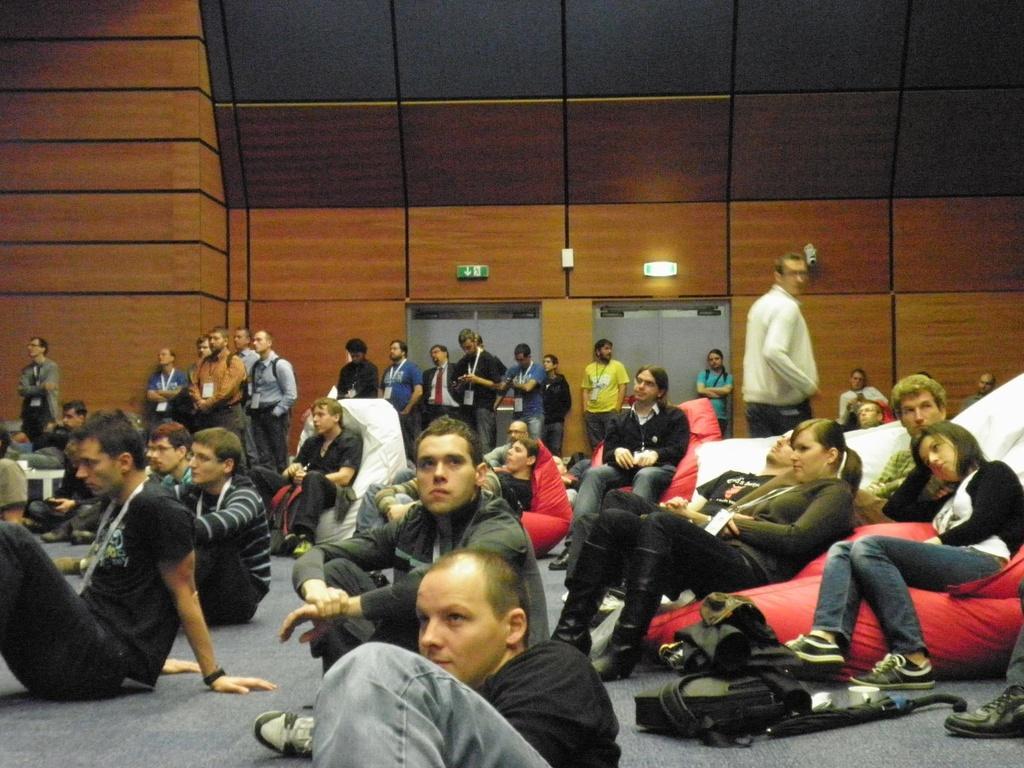In one or two sentences, can you explain what this image depicts? In this image, we can see a group of people. Few people are sitting. Here we can see few people are standing. Background we can see wall, doors and sign boards. 